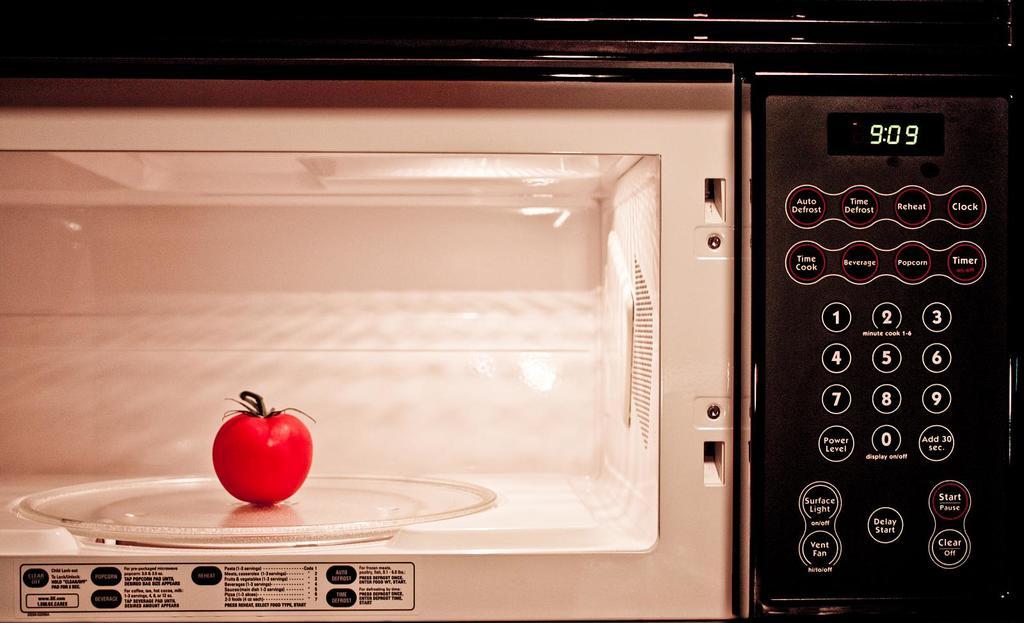What is the time?
Your answer should be compact. 9:09. What does the button on the left under the time say?
Provide a short and direct response. Auto defrost. 